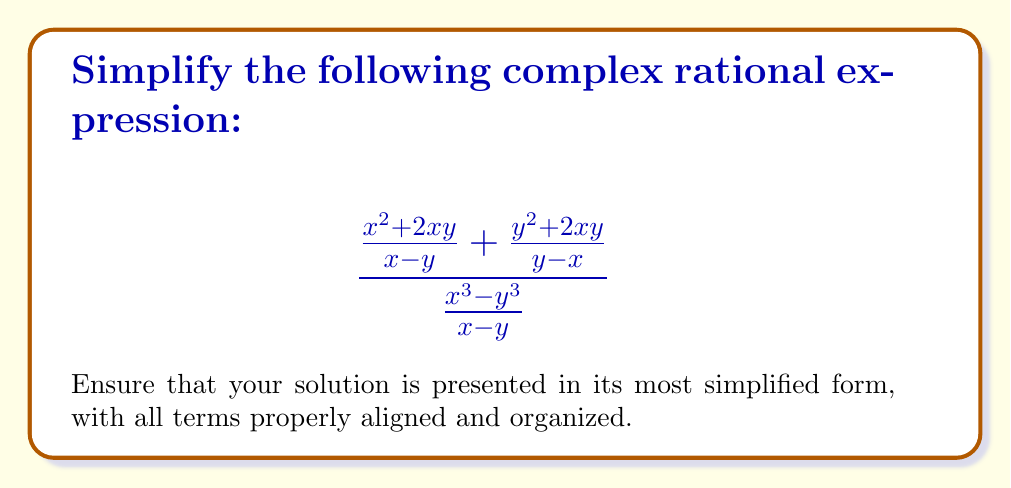Show me your answer to this math problem. Let's simplify this complex rational expression step by step:

1) First, let's simplify the numerator. We'll find a common denominator for the two fractions:

   $$\frac{x^2 + 2xy}{x - y} + \frac{y^2 + 2xy}{y - x} = \frac{(x^2 + 2xy)(y - x) + (y^2 + 2xy)(x - y)}{(x - y)(y - x)}$$

2) Expand the numerator:

   $$\frac{x^2y - x^3 + 2xy^2 - 2x^2y + xy^2 - y^3 + 2x^2y - 2xy^2}{-(x - y)^2}$$

3) Simplify the numerator:

   $$\frac{-x^3 - y^3 + xy^2 + x^2y}{(x - y)^2}$$

4) Now our complex fraction looks like this:

   $$\frac{\frac{-x^3 - y^3 + xy^2 + x^2y}{(x - y)^2}}{\frac{x^3 - y^3}{x - y}}$$

5) To divide fractions, we multiply by the reciprocal:

   $$\frac{-x^3 - y^3 + xy^2 + x^2y}{(x - y)^2} \cdot \frac{x - y}{x^3 - y^3}$$

6) Cancel out $(x - y)$ in numerator and denominator:

   $$\frac{-x^3 - y^3 + xy^2 + x^2y}{(x - y)(x^3 - y^3)}$$

7) Factor the denominator:

   $$\frac{-x^3 - y^3 + xy^2 + x^2y}{(x - y)(x^2 + xy + y^2)}$$

8) The numerator can be factored as $-(x + y)(x^2 - xy + y^2)$:

   $$\frac{-(x + y)(x^2 - xy + y^2)}{(x - y)(x^2 + xy + y^2)}$$

9) Final simplification:

   $$-\frac{x + y}{x - y}$$
Answer: $-\frac{x + y}{x - y}$ 